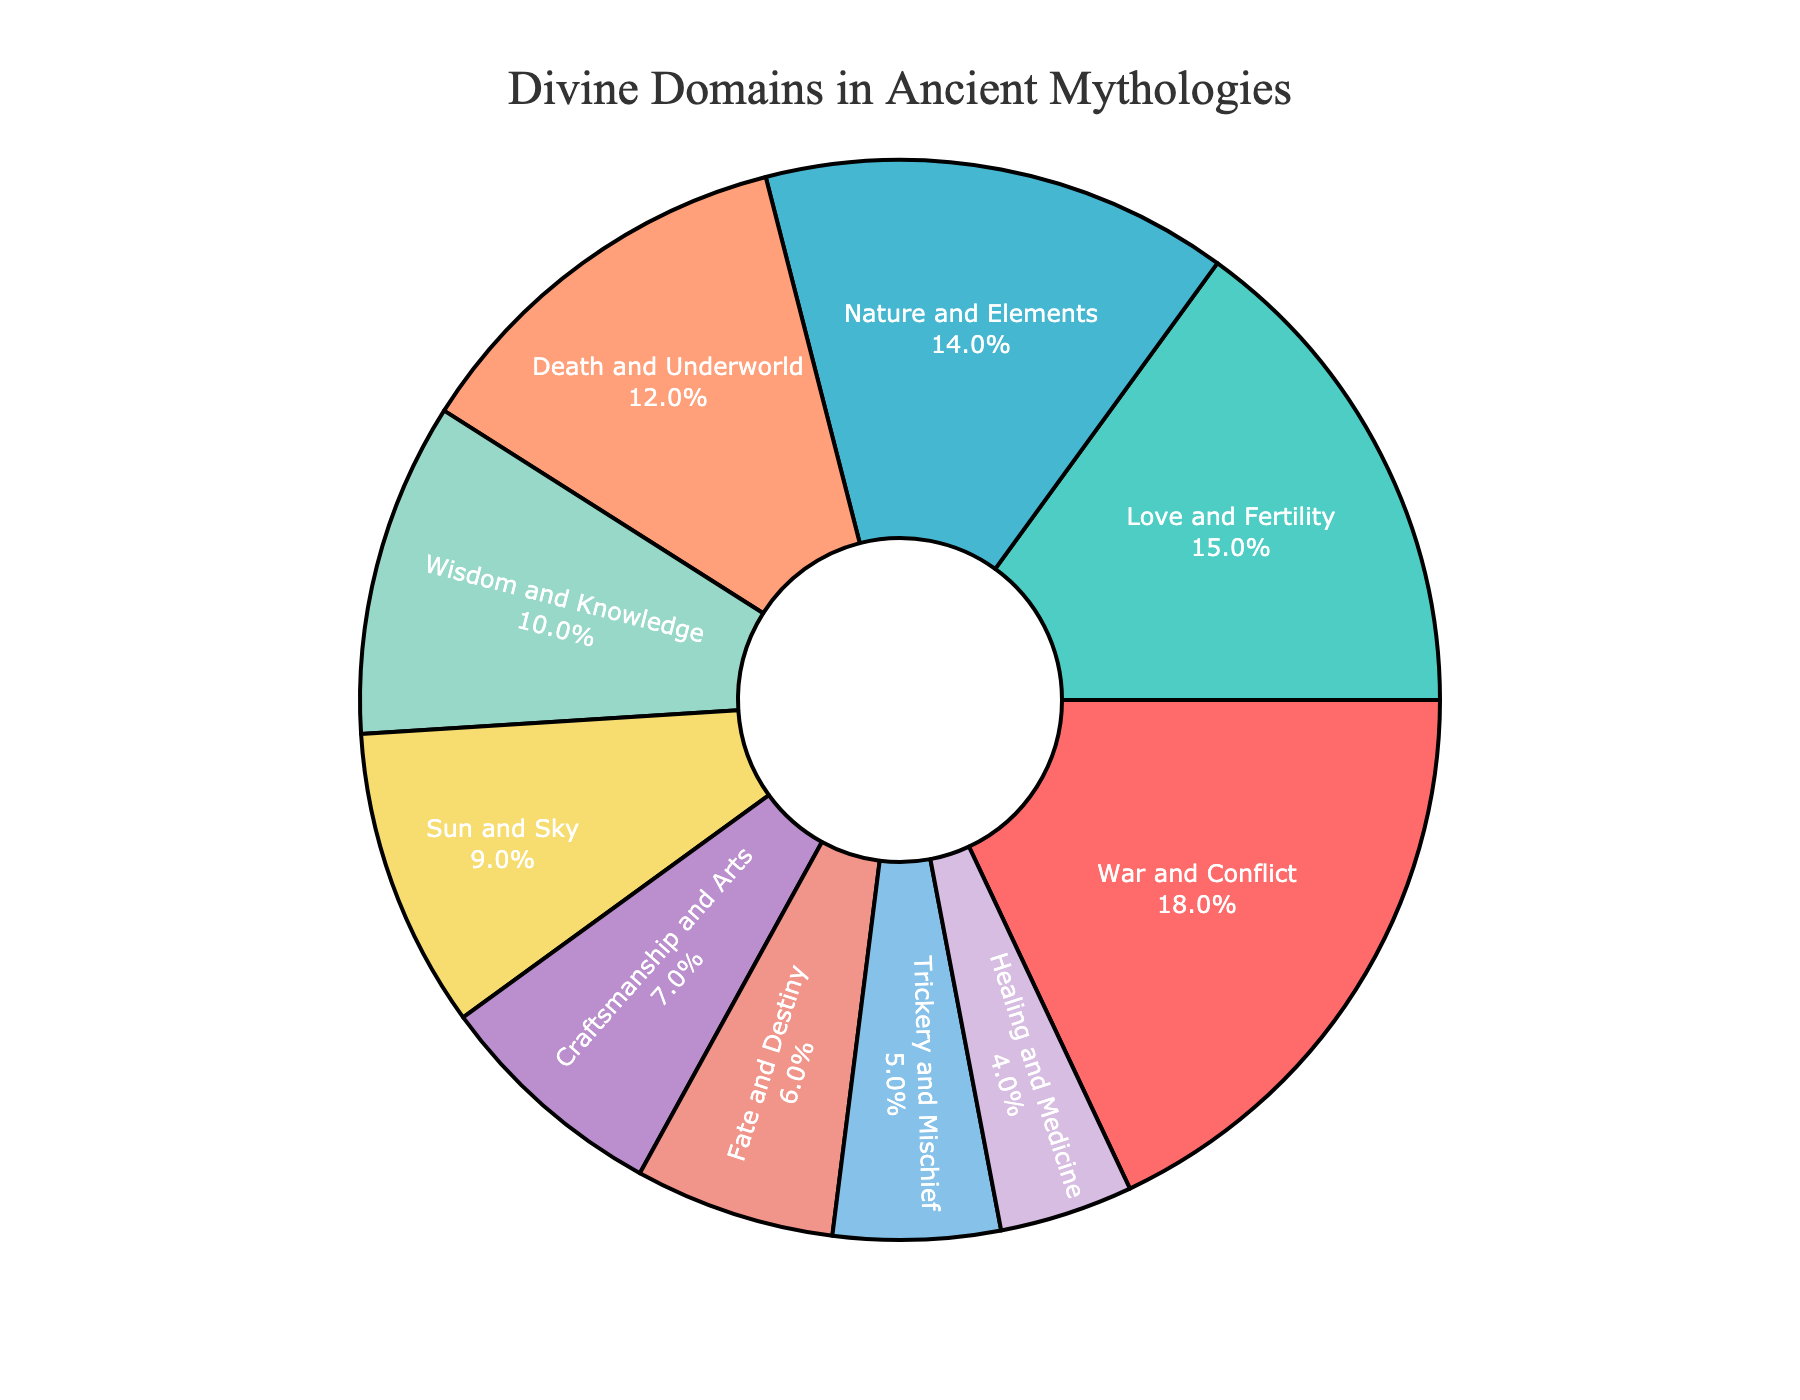What percentage of the pantheon does 'War and Conflict' occupy? 'War and Conflict' is visually represented in the figure, and its associated percentage label shows that it occupies 18% of the divine domains
Answer: 18% Which divine domain has a larger proportion: 'War and Conflict' or 'Love and Fertility'? By comparing the visual segments and their percentage values, 'War and Conflict' (18%) is larger than 'Love and Fertility' (15%)
Answer: War and Conflict What is the combined percentage of 'Wisdom and Knowledge' and 'Healing and Medicine'? Adding the percentages for 'Wisdom and Knowledge' (10%) and 'Healing and Medicine' (4%) results in 10% + 4% = 14%
Answer: 14% Is the percentage of 'Nature and Elements' greater than or less than 'Death and Underworld'? Comparing the textual information, 'Nature and Elements' is 14%, whereas 'Death and Underworld' is 12%. Therefore, 'Nature and Elements' is greater
Answer: Greater Which domain has the smallest proportion in the pantheon? By examining the visual segments and their labels, 'Healing and Medicine' has the smallest proportion at 4%
Answer: Healing and Medicine How much more percentage does 'War and Conflict' have compared to 'Sun and Sky'? Subtracting the percentage of 'Sun and Sky' (9%) from 'War and Conflict' (18%) gives 18% - 9% = 9%
Answer: 9% What is the percentage difference between 'Fate and Destiny' and 'Craftsmanship and Arts'? Subtracting the percentage of 'Fate and Destiny' (6%) from 'Craftsmanship and Arts' (7%) gives 7% - 6% = 1%
Answer: 1% Are there more divine domains related to 'Craftsmanship and Arts' or 'Trickery and Mischief'? By examining the figure, 'Craftsmanship and Arts' has 7%, whereas 'Trickery and Mischief' has 5%. Therefore, 'Craftsmanship and Arts' has a larger proportion
Answer: Craftsmanship and Arts What is the total percentage of the domains that occupy less than or equal to 10%? Summing up 'Wisdom and Knowledge' (10%), 'Sun and Sky' (9%), 'Craftsmanship and Arts' (7%), 'Fate and Destiny' (6%), 'Trickery and Mischief' (5%), and 'Healing and Medicine' (4%) gives 10% + 9% + 7% + 6% + 5% + 4% = 41%
Answer: 41% List the divine domains that have less than 10% share in the pantheon. Identifying the domains with less than 10% are 'Craftsmanship and Arts' (7%), 'Fate and Destiny' (6%), 'Trickery and Mischief' (5%), and 'Healing and Medicine' (4%)
Answer: Craftsmanship and Arts, Fate and Destiny, Trickery and Mischief, Healing and Medicine 